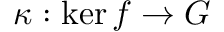<formula> <loc_0><loc_0><loc_500><loc_500>\kappa \colon \ker f \rightarrow G</formula> 